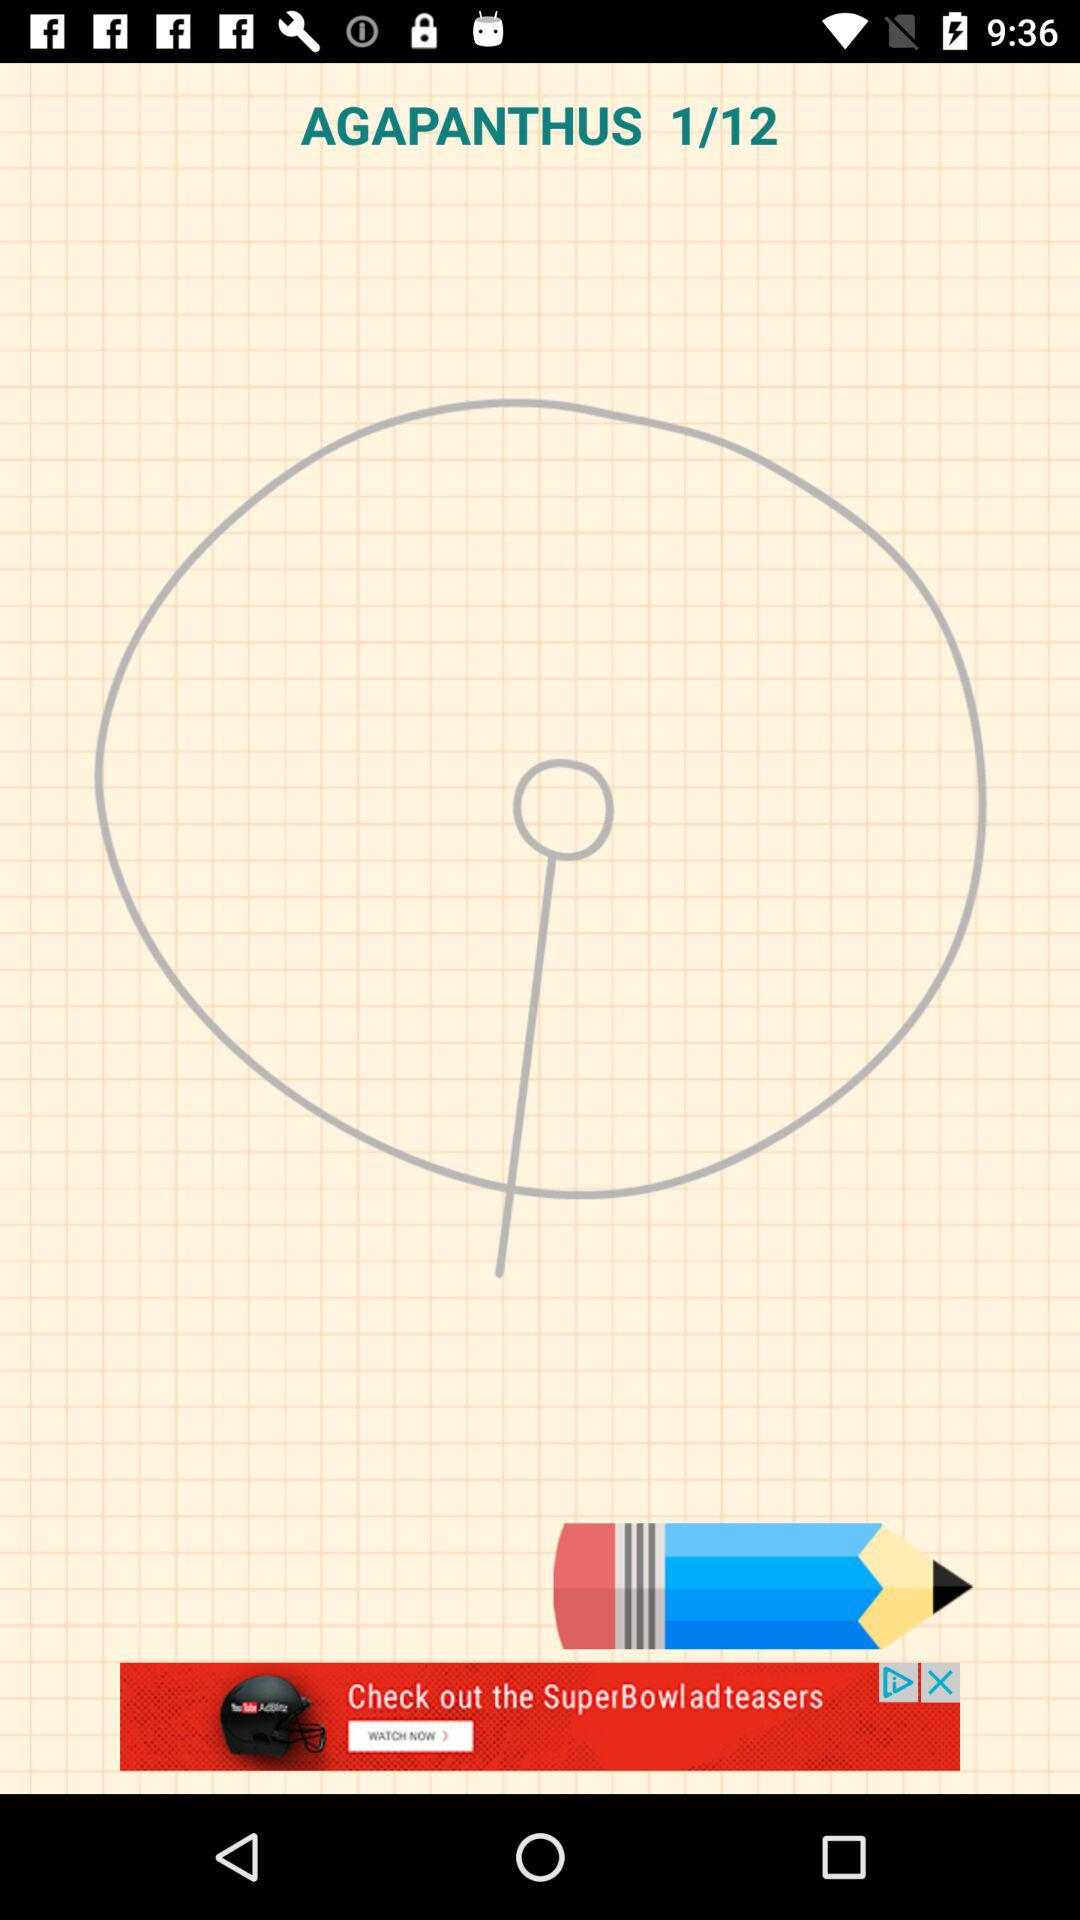How many pages in total are there? There are 12 pages. 